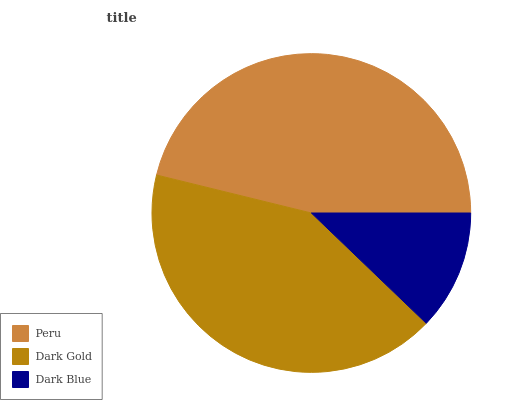Is Dark Blue the minimum?
Answer yes or no. Yes. Is Peru the maximum?
Answer yes or no. Yes. Is Dark Gold the minimum?
Answer yes or no. No. Is Dark Gold the maximum?
Answer yes or no. No. Is Peru greater than Dark Gold?
Answer yes or no. Yes. Is Dark Gold less than Peru?
Answer yes or no. Yes. Is Dark Gold greater than Peru?
Answer yes or no. No. Is Peru less than Dark Gold?
Answer yes or no. No. Is Dark Gold the high median?
Answer yes or no. Yes. Is Dark Gold the low median?
Answer yes or no. Yes. Is Peru the high median?
Answer yes or no. No. Is Peru the low median?
Answer yes or no. No. 